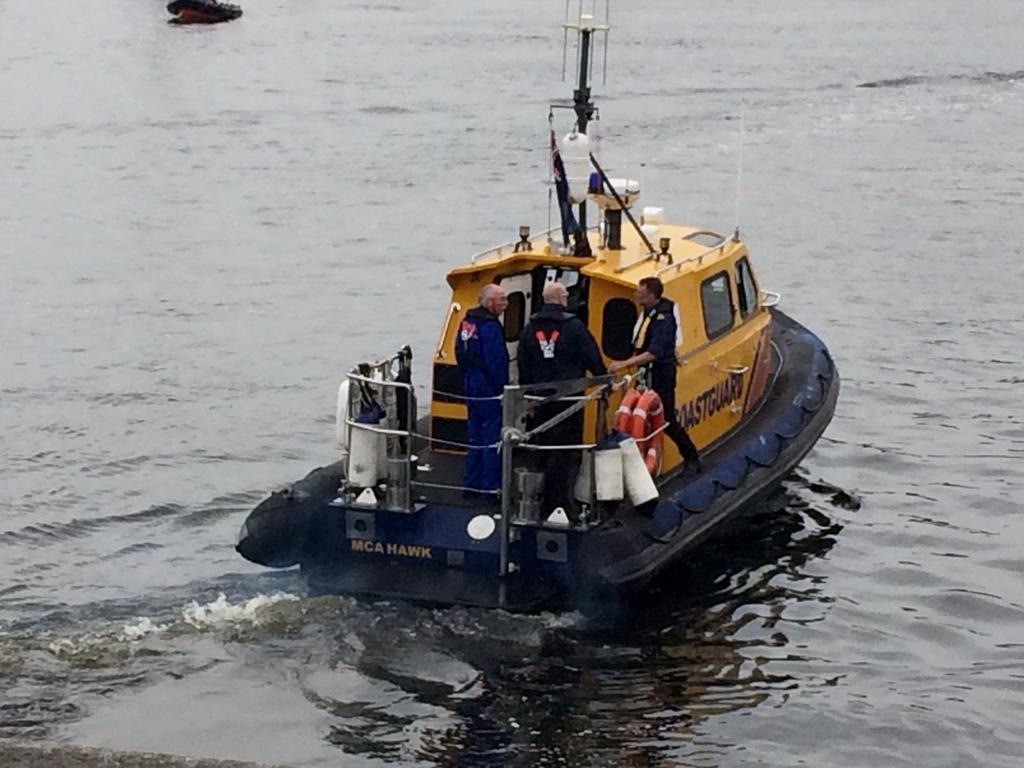Can you describe this image briefly? In this picture we can see there are three men standing on the boat and the boat is on the water. 